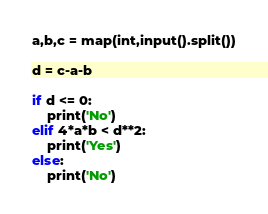<code> <loc_0><loc_0><loc_500><loc_500><_Python_>a,b,c = map(int,input().split())

d = c-a-b

if d <= 0:
    print('No')
elif 4*a*b < d**2:
    print('Yes')
else:
    print('No')</code> 